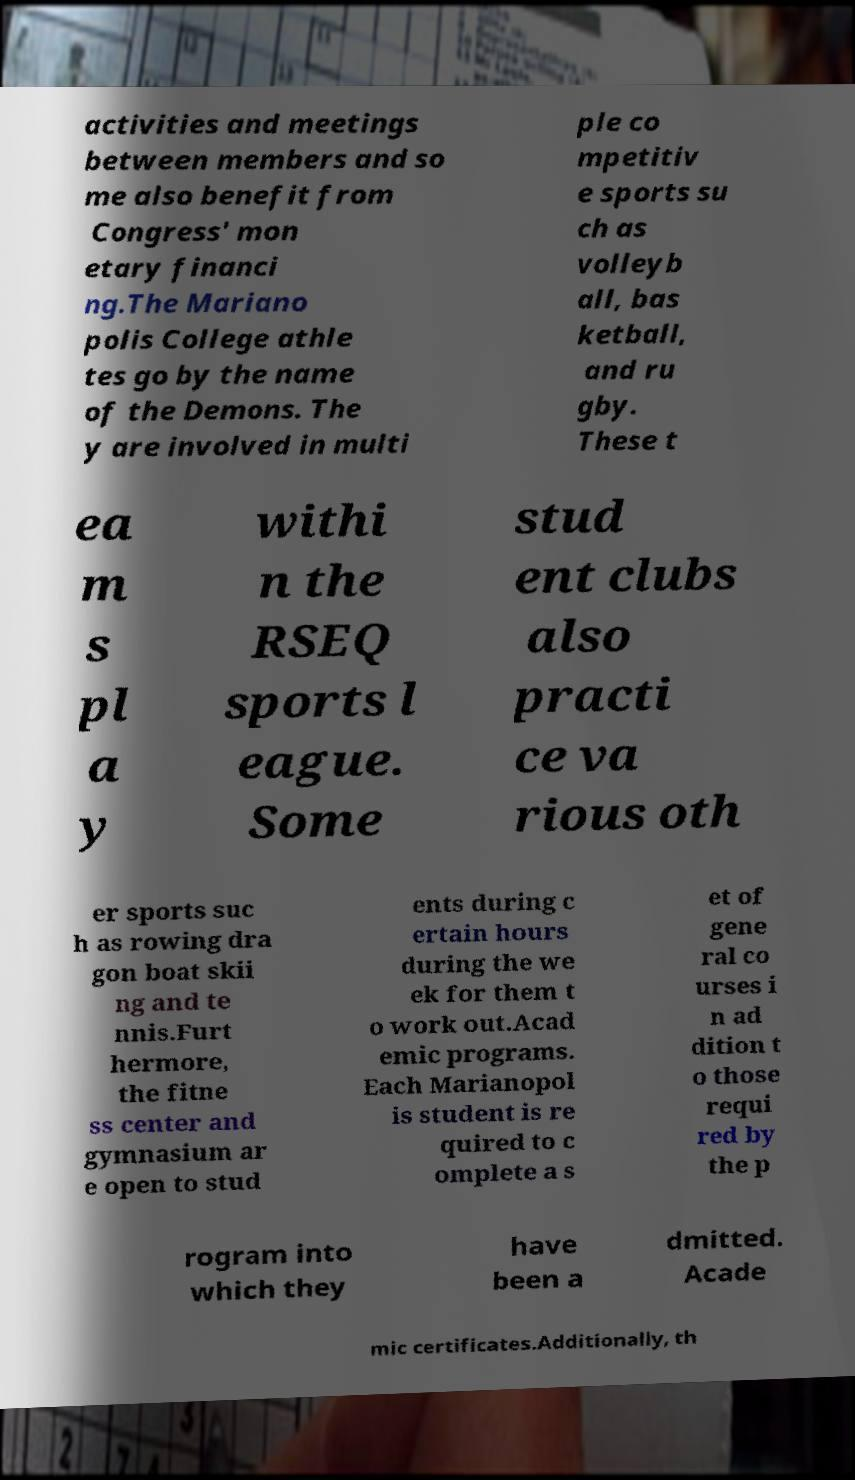I need the written content from this picture converted into text. Can you do that? activities and meetings between members and so me also benefit from Congress' mon etary financi ng.The Mariano polis College athle tes go by the name of the Demons. The y are involved in multi ple co mpetitiv e sports su ch as volleyb all, bas ketball, and ru gby. These t ea m s pl a y withi n the RSEQ sports l eague. Some stud ent clubs also practi ce va rious oth er sports suc h as rowing dra gon boat skii ng and te nnis.Furt hermore, the fitne ss center and gymnasium ar e open to stud ents during c ertain hours during the we ek for them t o work out.Acad emic programs. Each Marianopol is student is re quired to c omplete a s et of gene ral co urses i n ad dition t o those requi red by the p rogram into which they have been a dmitted. Acade mic certificates.Additionally, th 